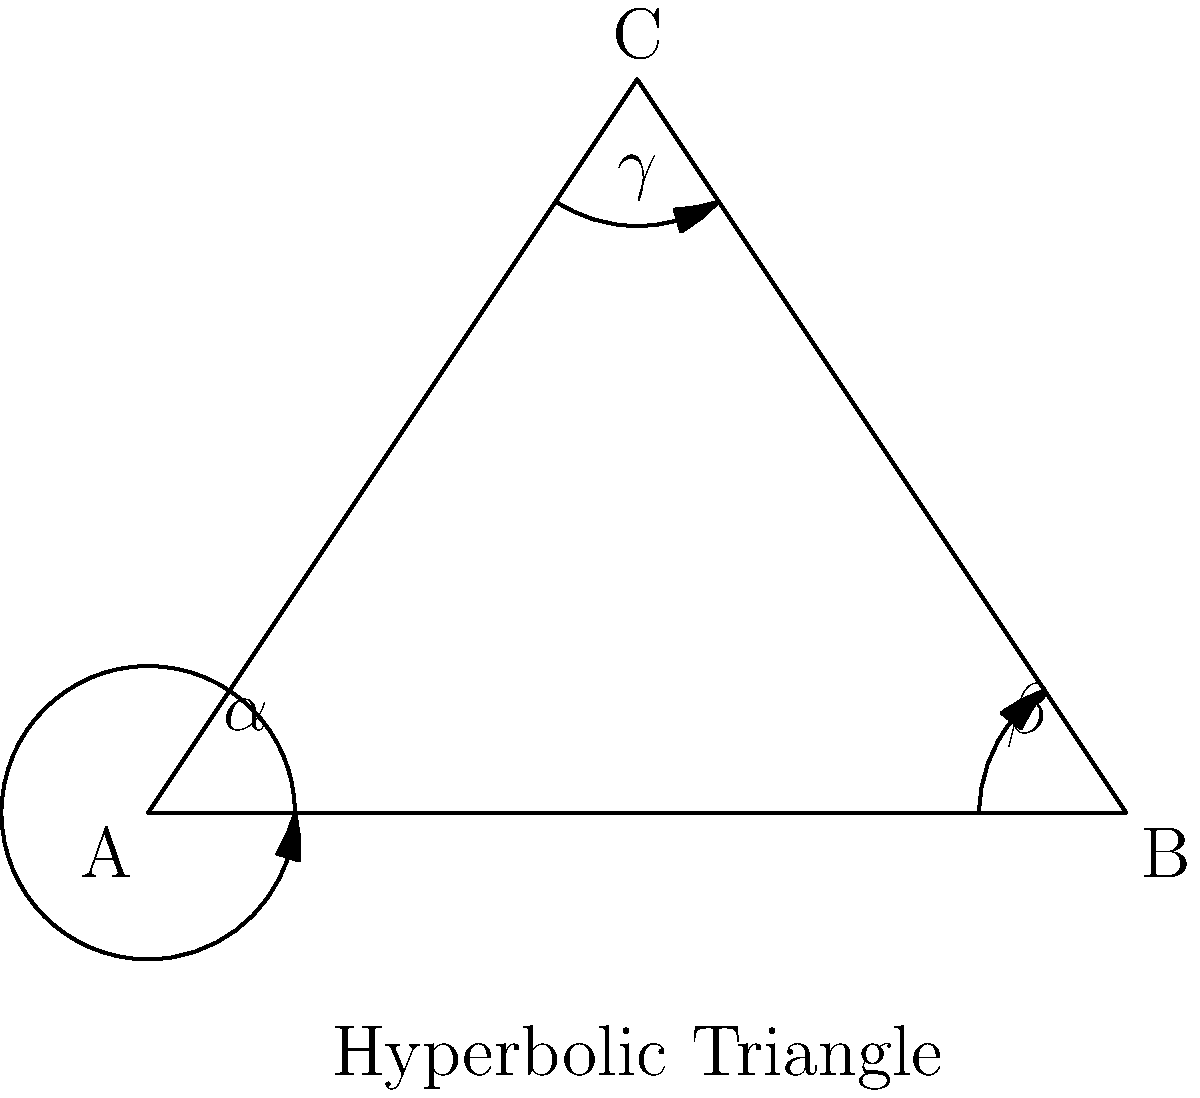In a hyperbolic triangle ABC, the angles $\alpha$, $\beta$, and $\gamma$ satisfy the equation $\alpha + \beta + \gamma = k\pi$, where $k$ is a constant. If the area of the triangle is $\frac{\pi}{4}$, what is the value of $k$? (Hint: In hyperbolic geometry, the area of a triangle is proportional to its angle defect.) To solve this problem, let's follow these steps:

1) In Euclidean geometry, the sum of angles in a triangle is always $\pi$. However, in hyperbolic geometry, this sum is less than $\pi$.

2) The difference between $\pi$ and the sum of angles in a hyperbolic triangle is called the angle defect. It's directly proportional to the area of the triangle.

3) The relationship between the area (A) of a hyperbolic triangle and its angles is given by the Gauss-Bonnet formula:

   $A = \pi - (\alpha + \beta + \gamma)$

4) We're given that $\alpha + \beta + \gamma = k\pi$ and the area is $\frac{\pi}{4}$.

5) Substituting these into the Gauss-Bonnet formula:

   $\frac{\pi}{4} = \pi - k\pi$

6) Simplifying:

   $\frac{\pi}{4} = \pi(1 - k)$

7) Dividing both sides by $\pi$:

   $\frac{1}{4} = 1 - k$

8) Solving for $k$:

   $k = 1 - \frac{1}{4} = \frac{3}{4}$

Therefore, the value of $k$ is $\frac{3}{4}$.
Answer: $\frac{3}{4}$ 